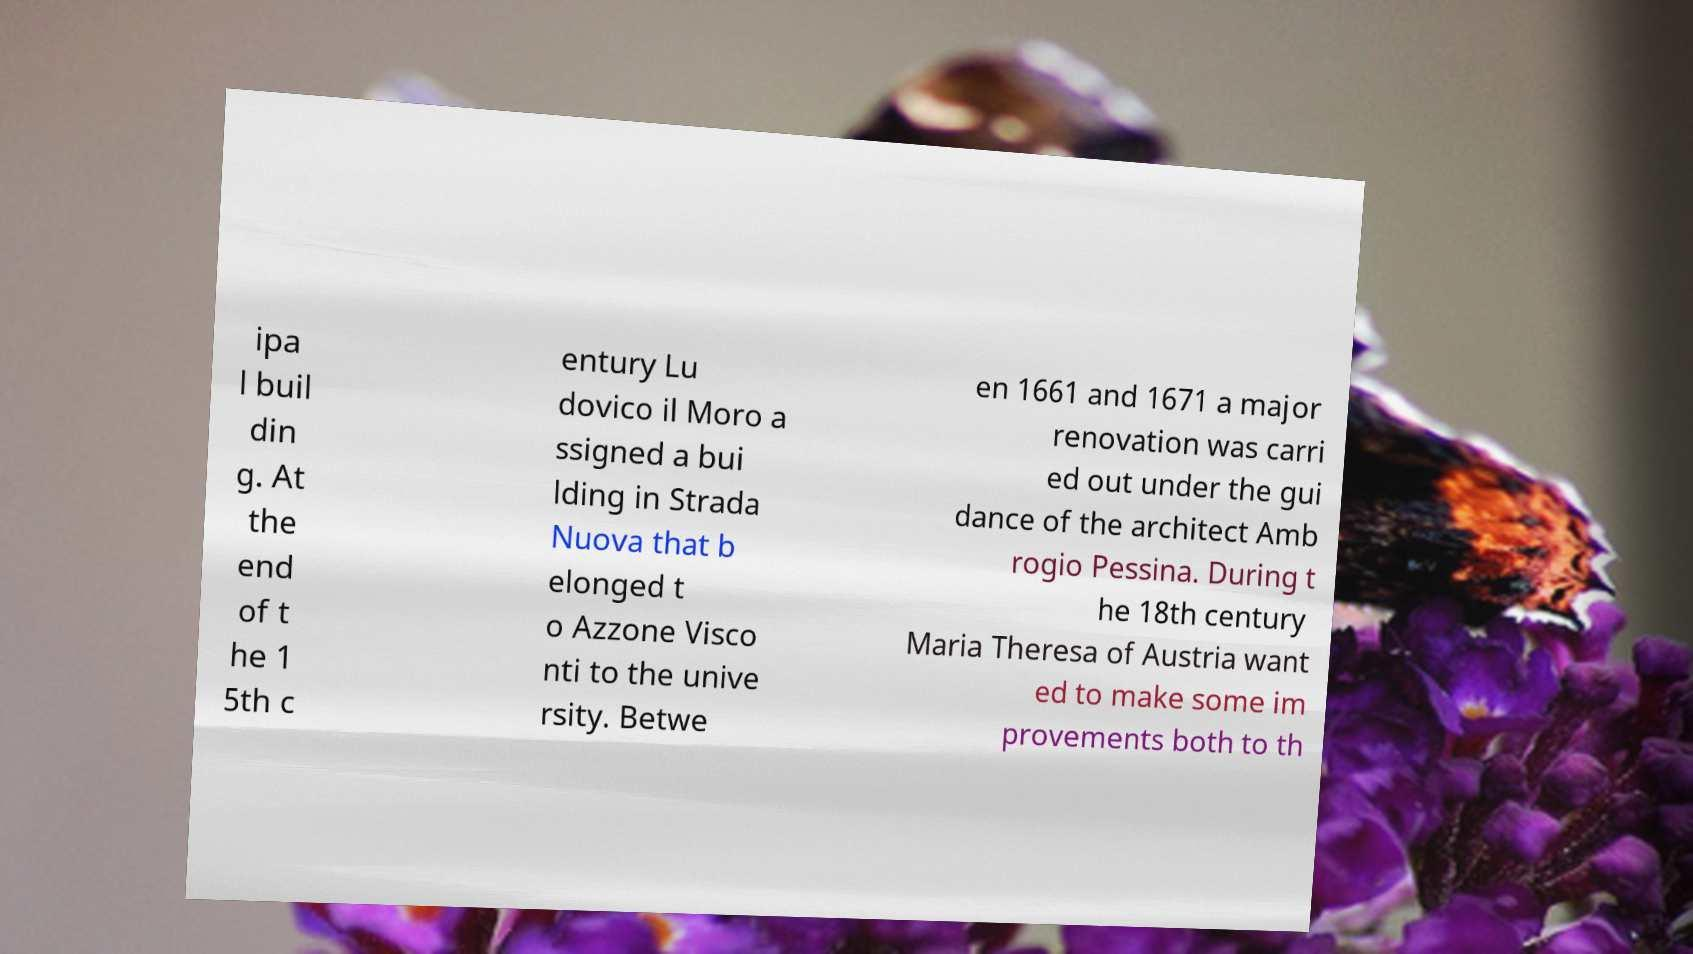Please identify and transcribe the text found in this image. ipa l buil din g. At the end of t he 1 5th c entury Lu dovico il Moro a ssigned a bui lding in Strada Nuova that b elonged t o Azzone Visco nti to the unive rsity. Betwe en 1661 and 1671 a major renovation was carri ed out under the gui dance of the architect Amb rogio Pessina. During t he 18th century Maria Theresa of Austria want ed to make some im provements both to th 